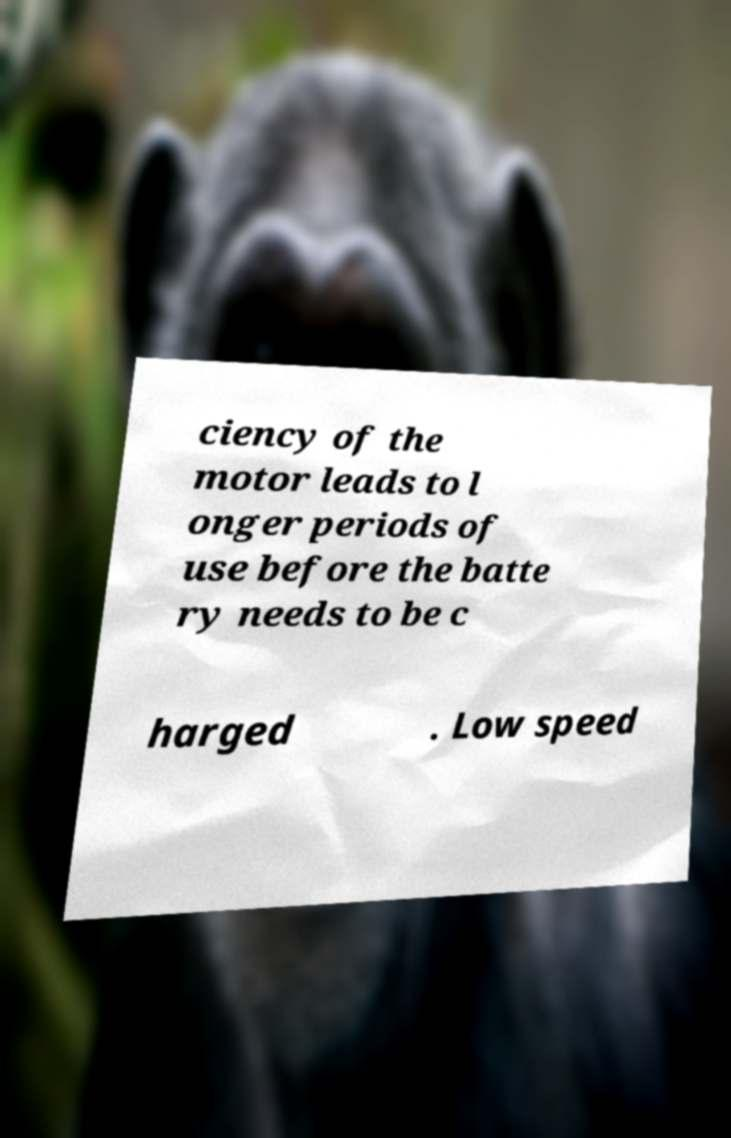Could you extract and type out the text from this image? ciency of the motor leads to l onger periods of use before the batte ry needs to be c harged . Low speed 